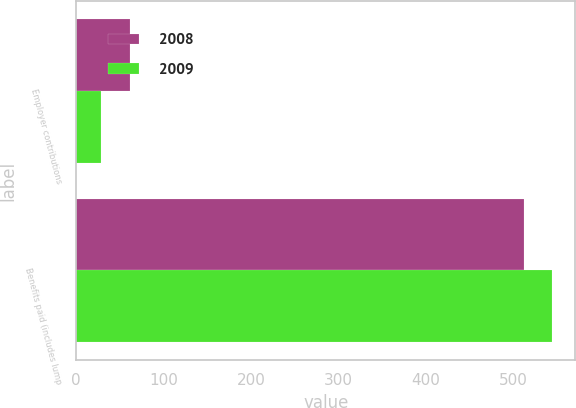Convert chart. <chart><loc_0><loc_0><loc_500><loc_500><stacked_bar_chart><ecel><fcel>Employer contributions<fcel>Benefits paid (includes lump<nl><fcel>2008<fcel>62<fcel>513<nl><fcel>2009<fcel>28<fcel>544<nl></chart> 